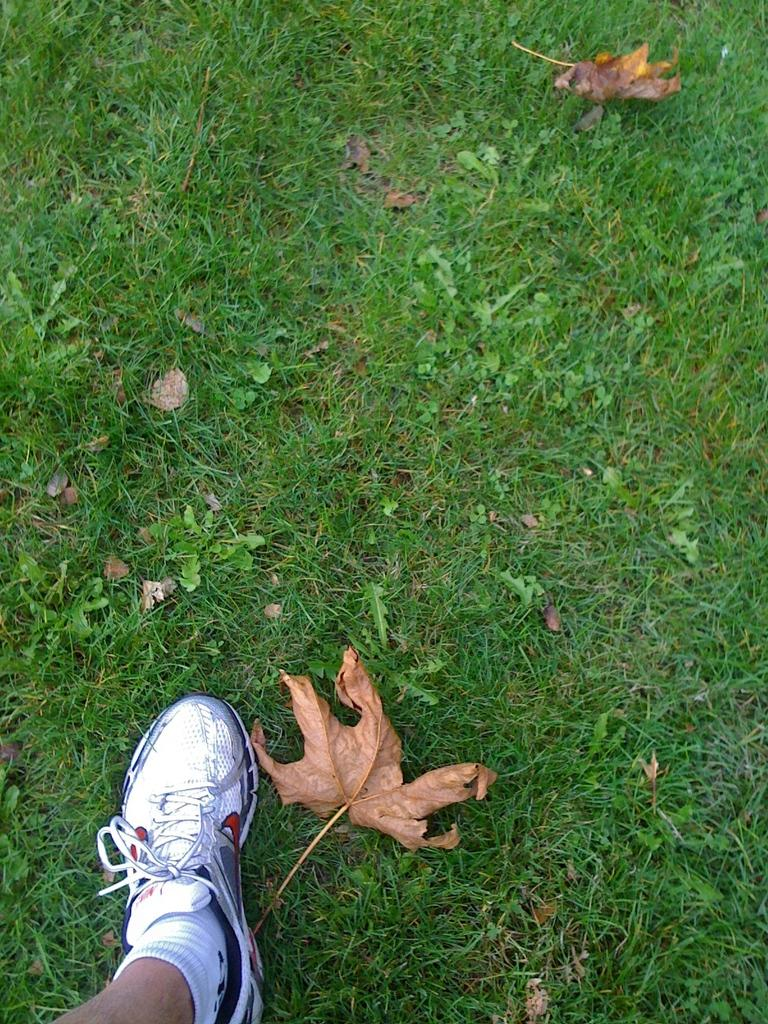What type of surface is on the ground in the image? There is grass on the ground in the image. What type of plant material can be seen in the image? There are leaves visible in the image. What part of a person's body is present in the image? A person's leg is present in the image. What type of clothing is covering the person's leg in the image? The person's leg is wearing socks and a shoe in the image. How many apples are being held by the person in the image? There are no apples present in the image. What type of error can be seen in the image? There is no error present in the image. 